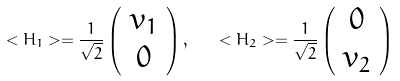<formula> <loc_0><loc_0><loc_500><loc_500>< H _ { 1 } > = \frac { 1 } { \sqrt { 2 } } \left ( \begin{array} { c } v _ { 1 } \\ 0 \end{array} \right ) , \quad < H _ { 2 } > = \frac { 1 } { \sqrt { 2 } } \left ( \begin{array} { c } 0 \\ v _ { 2 } \end{array} \right ) \,</formula> 